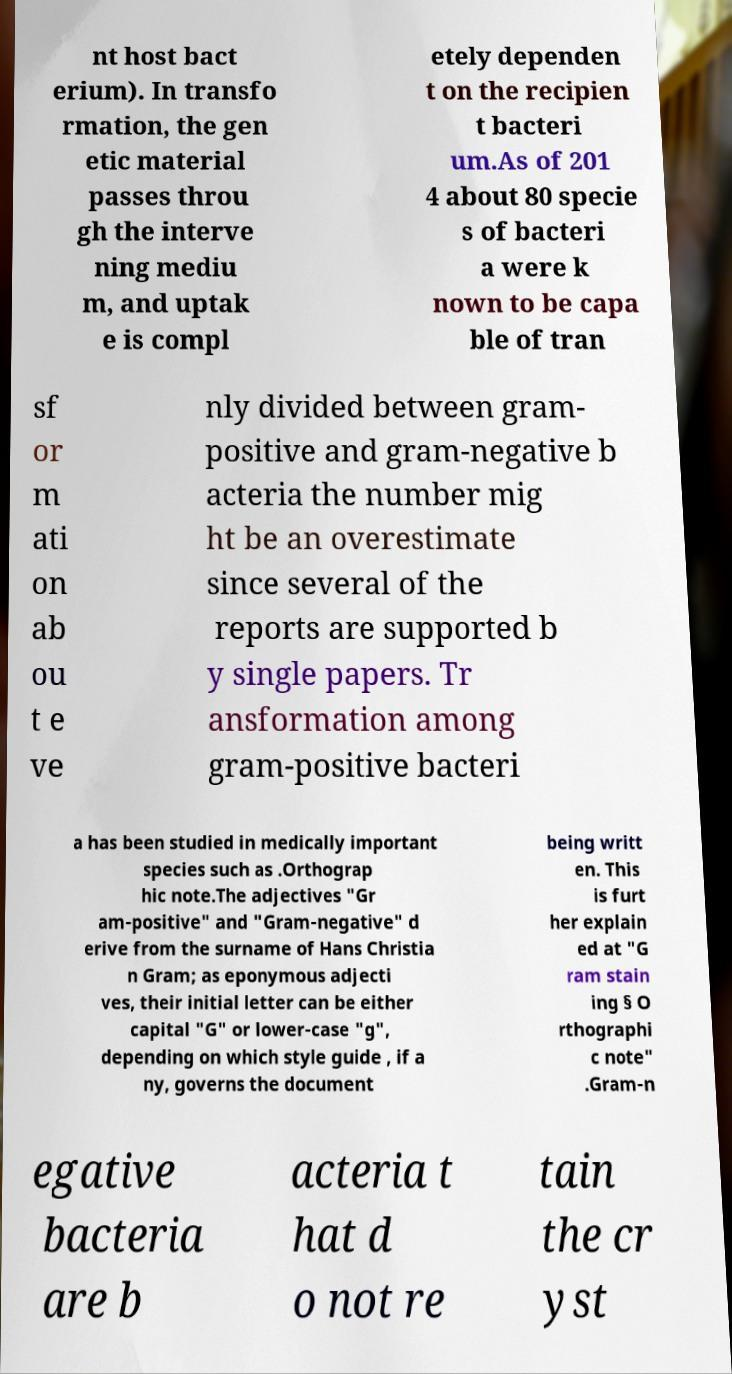I need the written content from this picture converted into text. Can you do that? nt host bact erium). In transfo rmation, the gen etic material passes throu gh the interve ning mediu m, and uptak e is compl etely dependen t on the recipien t bacteri um.As of 201 4 about 80 specie s of bacteri a were k nown to be capa ble of tran sf or m ati on ab ou t e ve nly divided between gram- positive and gram-negative b acteria the number mig ht be an overestimate since several of the reports are supported b y single papers. Tr ansformation among gram-positive bacteri a has been studied in medically important species such as .Orthograp hic note.The adjectives "Gr am-positive" and "Gram-negative" d erive from the surname of Hans Christia n Gram; as eponymous adjecti ves, their initial letter can be either capital "G" or lower-case "g", depending on which style guide , if a ny, governs the document being writt en. This is furt her explain ed at "G ram stain ing § O rthographi c note" .Gram-n egative bacteria are b acteria t hat d o not re tain the cr yst 